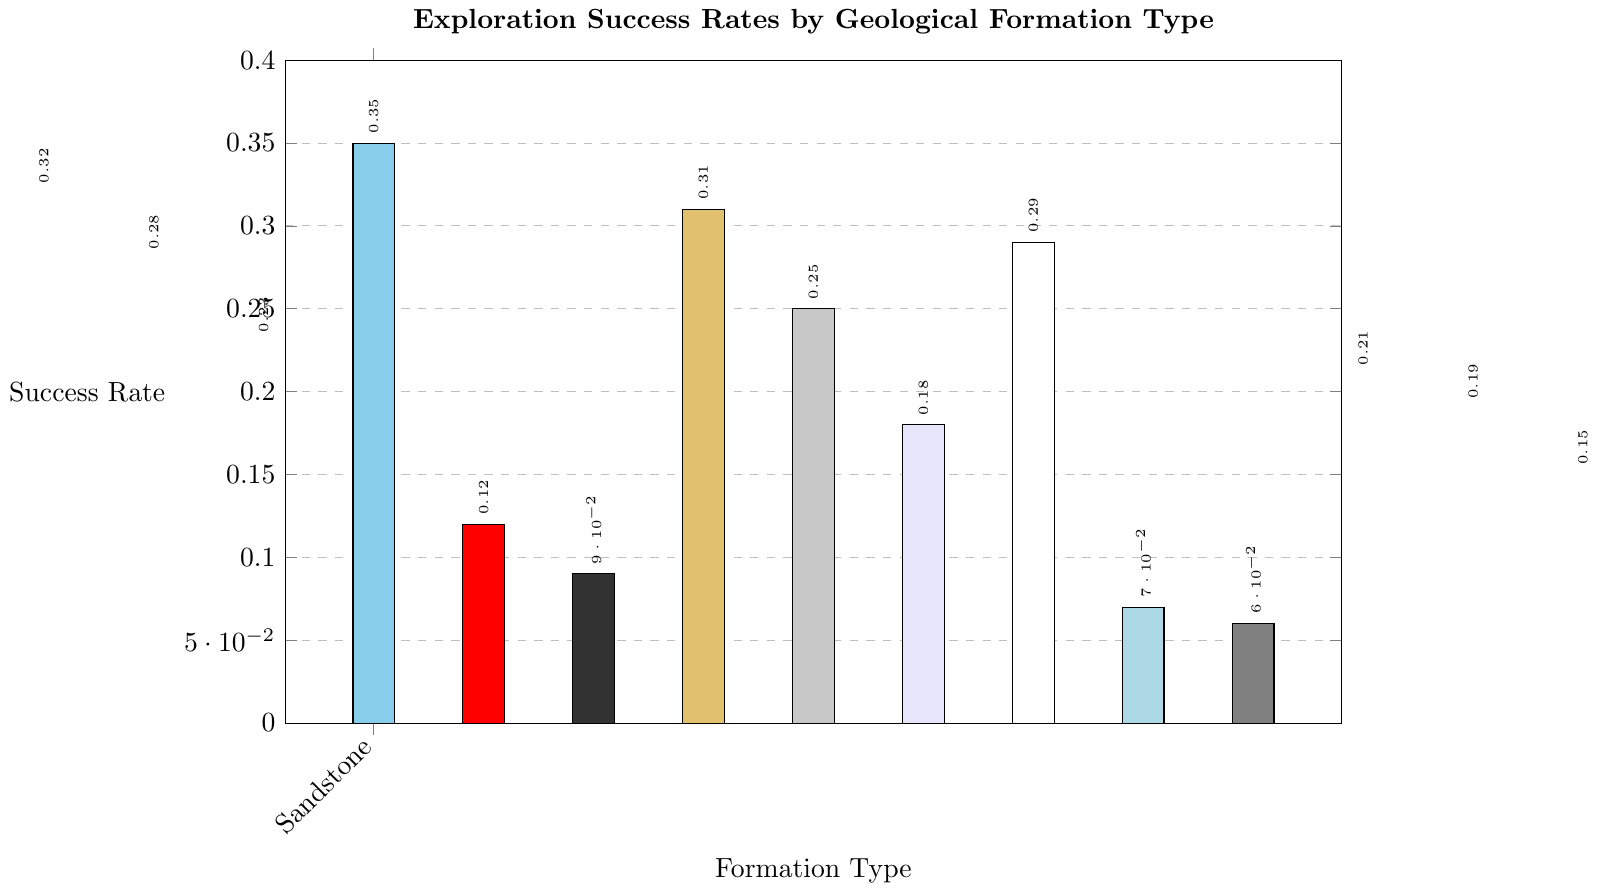Which geological formation type has the highest exploration success rate? By inspecting the highest bar in the chart, we can see that the Carbonate formation type achieves the greatest success rate.
Answer: Carbonate Which formation types have a success rate greater than 0.3? To determine the formation types with a success rate above 0.3, we look for bars that extend beyond the 0.3 mark and list their corresponding formation types. These are Sandstone, Carbonate, and Dolomite.
Answer: Sandstone, Carbonate, Dolomite What is the difference in success rates between Granit and Slate? By identifying the bars for Granite and Slate and noting their respective heights, we see that Granite's success rate is 0.12 and Slate's is 0.23. The difference is calculated as 0.23 - 0.12 = 0.11.
Answer: 0.11 Rank the following formation types by their success rates, from highest to lowest: Sandstone, Siltstone, Claystone, Conglomerate. First, identify the heights of the bars for each formation type: Sandstone (0.32), Siltstone (0.25), Claystone (0.21), Conglomerate (0.19). Then, order them from highest to lowest success rate.
Answer: Sandstone, Siltstone, Claystone, Conglomerate What's the average success rate of the formation types with a rate below 0.2? Identify bars with success rates lower than 0.2: Granite (0.12), Basalt (0.09), Anhydrite (0.18), Gneiss (0.07), Schist (0.06), and Coal (0.15). Sum these values: 0.12 + 0.09 + 0.18 + 0.07 + 0.06 + 0.15 = 0.67. The average is 0.67 / 6 = 0.1117.
Answer: 0.1117 Which formation type has the least exploration success rate and what is its color? By finding the lowest bar in the chart, we note that Schist has the least success rate, and its bar is colored grey.
Answer: Schist, grey How many formation types have success rates between 0.2 and 0.3? Count the bars whose heights fall between the 0.2 and 0.3 marks: Shale (0.23), Siltstone (0.25), Chalk (0.29), and Claystone (0.21).
Answer: 4 If we combine the success rates of Sandstone and Limestone, what is the total? Locate the bars for Sandstone (0.32) and Limestone (0.28) and sum their success rates: 0.32 + 0.28 = 0.60.
Answer: 0.60 Which geological formation type is the lightest color on the figure and what is its success rate? The lightest color on the figure corresponds to Chalk, which has a success rate of 0.29.
Answer: Chalk, 0.29 